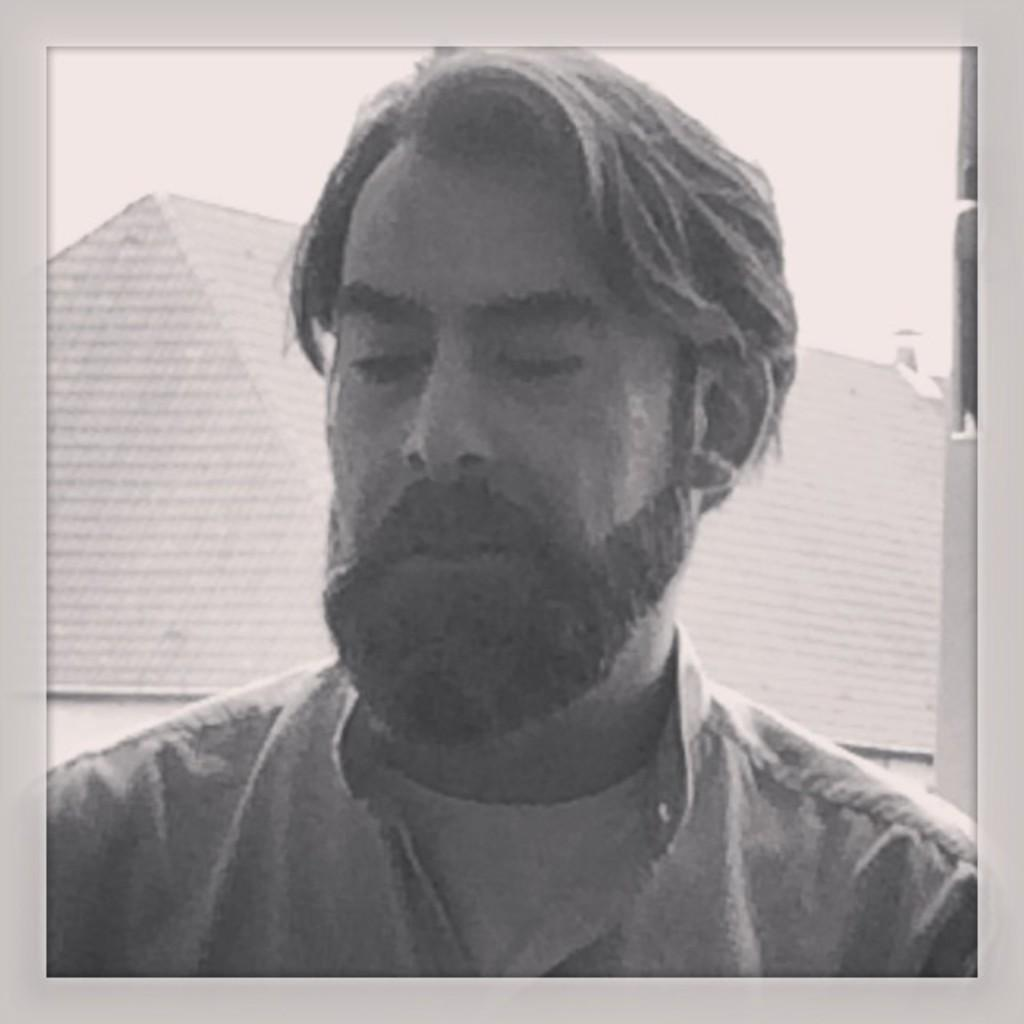What is the color scheme of the image? The image is black and white. Can you describe the main subject in the image? There is a person in the image. What can be seen in the background of the image? There are houses and the sky visible in the background of the image. How many trees are present in the image? There are no trees visible in the image; it features a person, houses, and the sky. What type of screw can be seen in the image? There is no screw present in the image. 